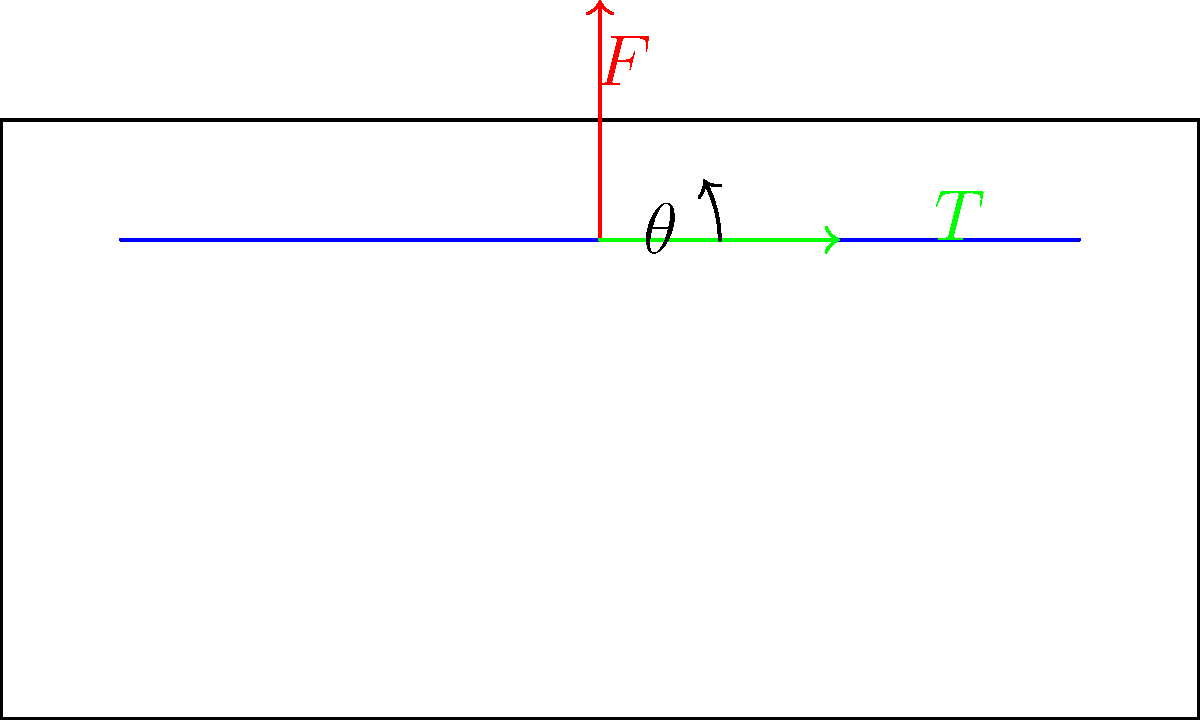In crafting a traditional Ahm family string instrument, a taut string is pulled perpendicular to its length with a force $F$ of 20 N, creating a small angle $\theta$ of 15° with the horizontal. Calculate the tension $T$ in the string. To solve this problem, we'll use the principles of force equilibrium in two dimensions. Here's a step-by-step approach:

1) In equilibrium, the sum of forces in both x and y directions must be zero.

2) Let's consider the y-direction first:
   $$F - 2T\sin\theta = 0$$

3) Rearranging this equation:
   $$2T\sin\theta = F$$
   $$T = \frac{F}{2\sin\theta}$$

4) We know that $F = 20$ N and $\theta = 15°$

5) Substituting these values:
   $$T = \frac{20}{2\sin(15°)}$$

6) Calculate $\sin(15°)$:
   $$\sin(15°) \approx 0.2588$$

7) Now we can compute T:
   $$T = \frac{20}{2(0.2588)} \approx 38.64 \text{ N}$$

Therefore, the tension in the string is approximately 38.64 N.
Answer: 38.64 N 